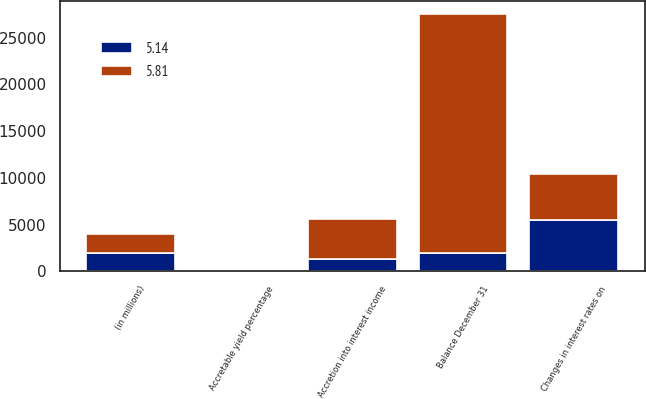<chart> <loc_0><loc_0><loc_500><loc_500><stacked_bar_chart><ecel><fcel>(in millions)<fcel>Accretion into interest income<fcel>Changes in interest rates on<fcel>Balance December 31<fcel>Accretable yield percentage<nl><fcel>5.81<fcel>2009<fcel>4363<fcel>4849<fcel>25544<fcel>5.14<nl><fcel>5.14<fcel>2008<fcel>1292<fcel>5543<fcel>2009<fcel>5.81<nl></chart> 